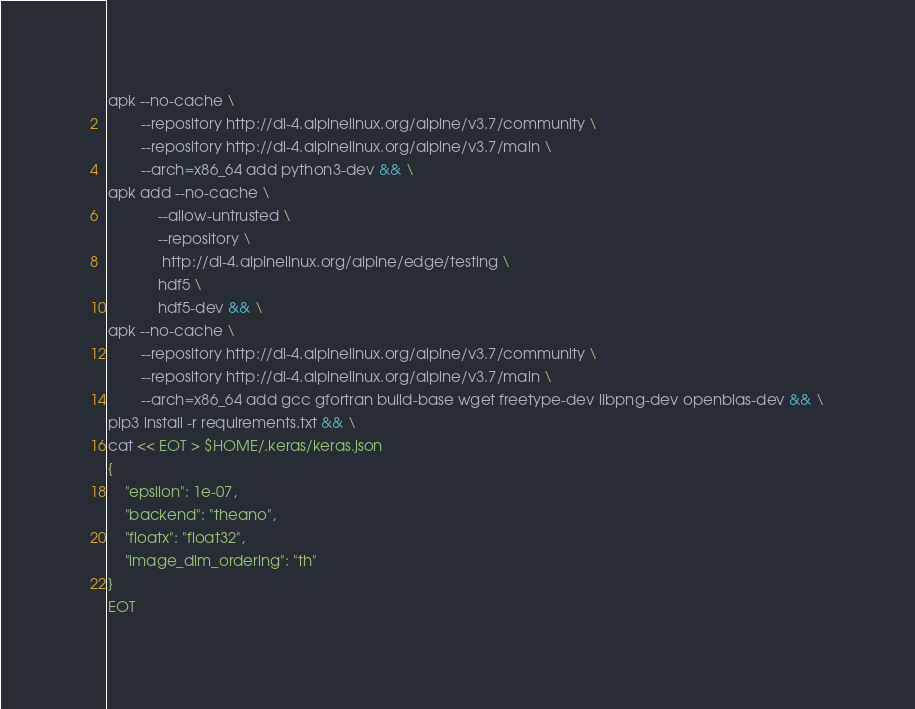Convert code to text. <code><loc_0><loc_0><loc_500><loc_500><_Bash_>apk --no-cache \
        --repository http://dl-4.alpinelinux.org/alpine/v3.7/community \
        --repository http://dl-4.alpinelinux.org/alpine/v3.7/main \
        --arch=x86_64 add python3-dev && \
apk add --no-cache \
            --allow-untrusted \
            --repository \
             http://dl-4.alpinelinux.org/alpine/edge/testing \
            hdf5 \
            hdf5-dev && \
apk --no-cache \
        --repository http://dl-4.alpinelinux.org/alpine/v3.7/community \
        --repository http://dl-4.alpinelinux.org/alpine/v3.7/main \
        --arch=x86_64 add gcc gfortran build-base wget freetype-dev libpng-dev openblas-dev && \
pip3 install -r requirements.txt && \
cat << EOT > $HOME/.keras/keras.json 
{
    "epsilon": 1e-07,
    "backend": "theano",
    "floatx": "float32",
    "image_dim_ordering": "th"
}
EOT</code> 